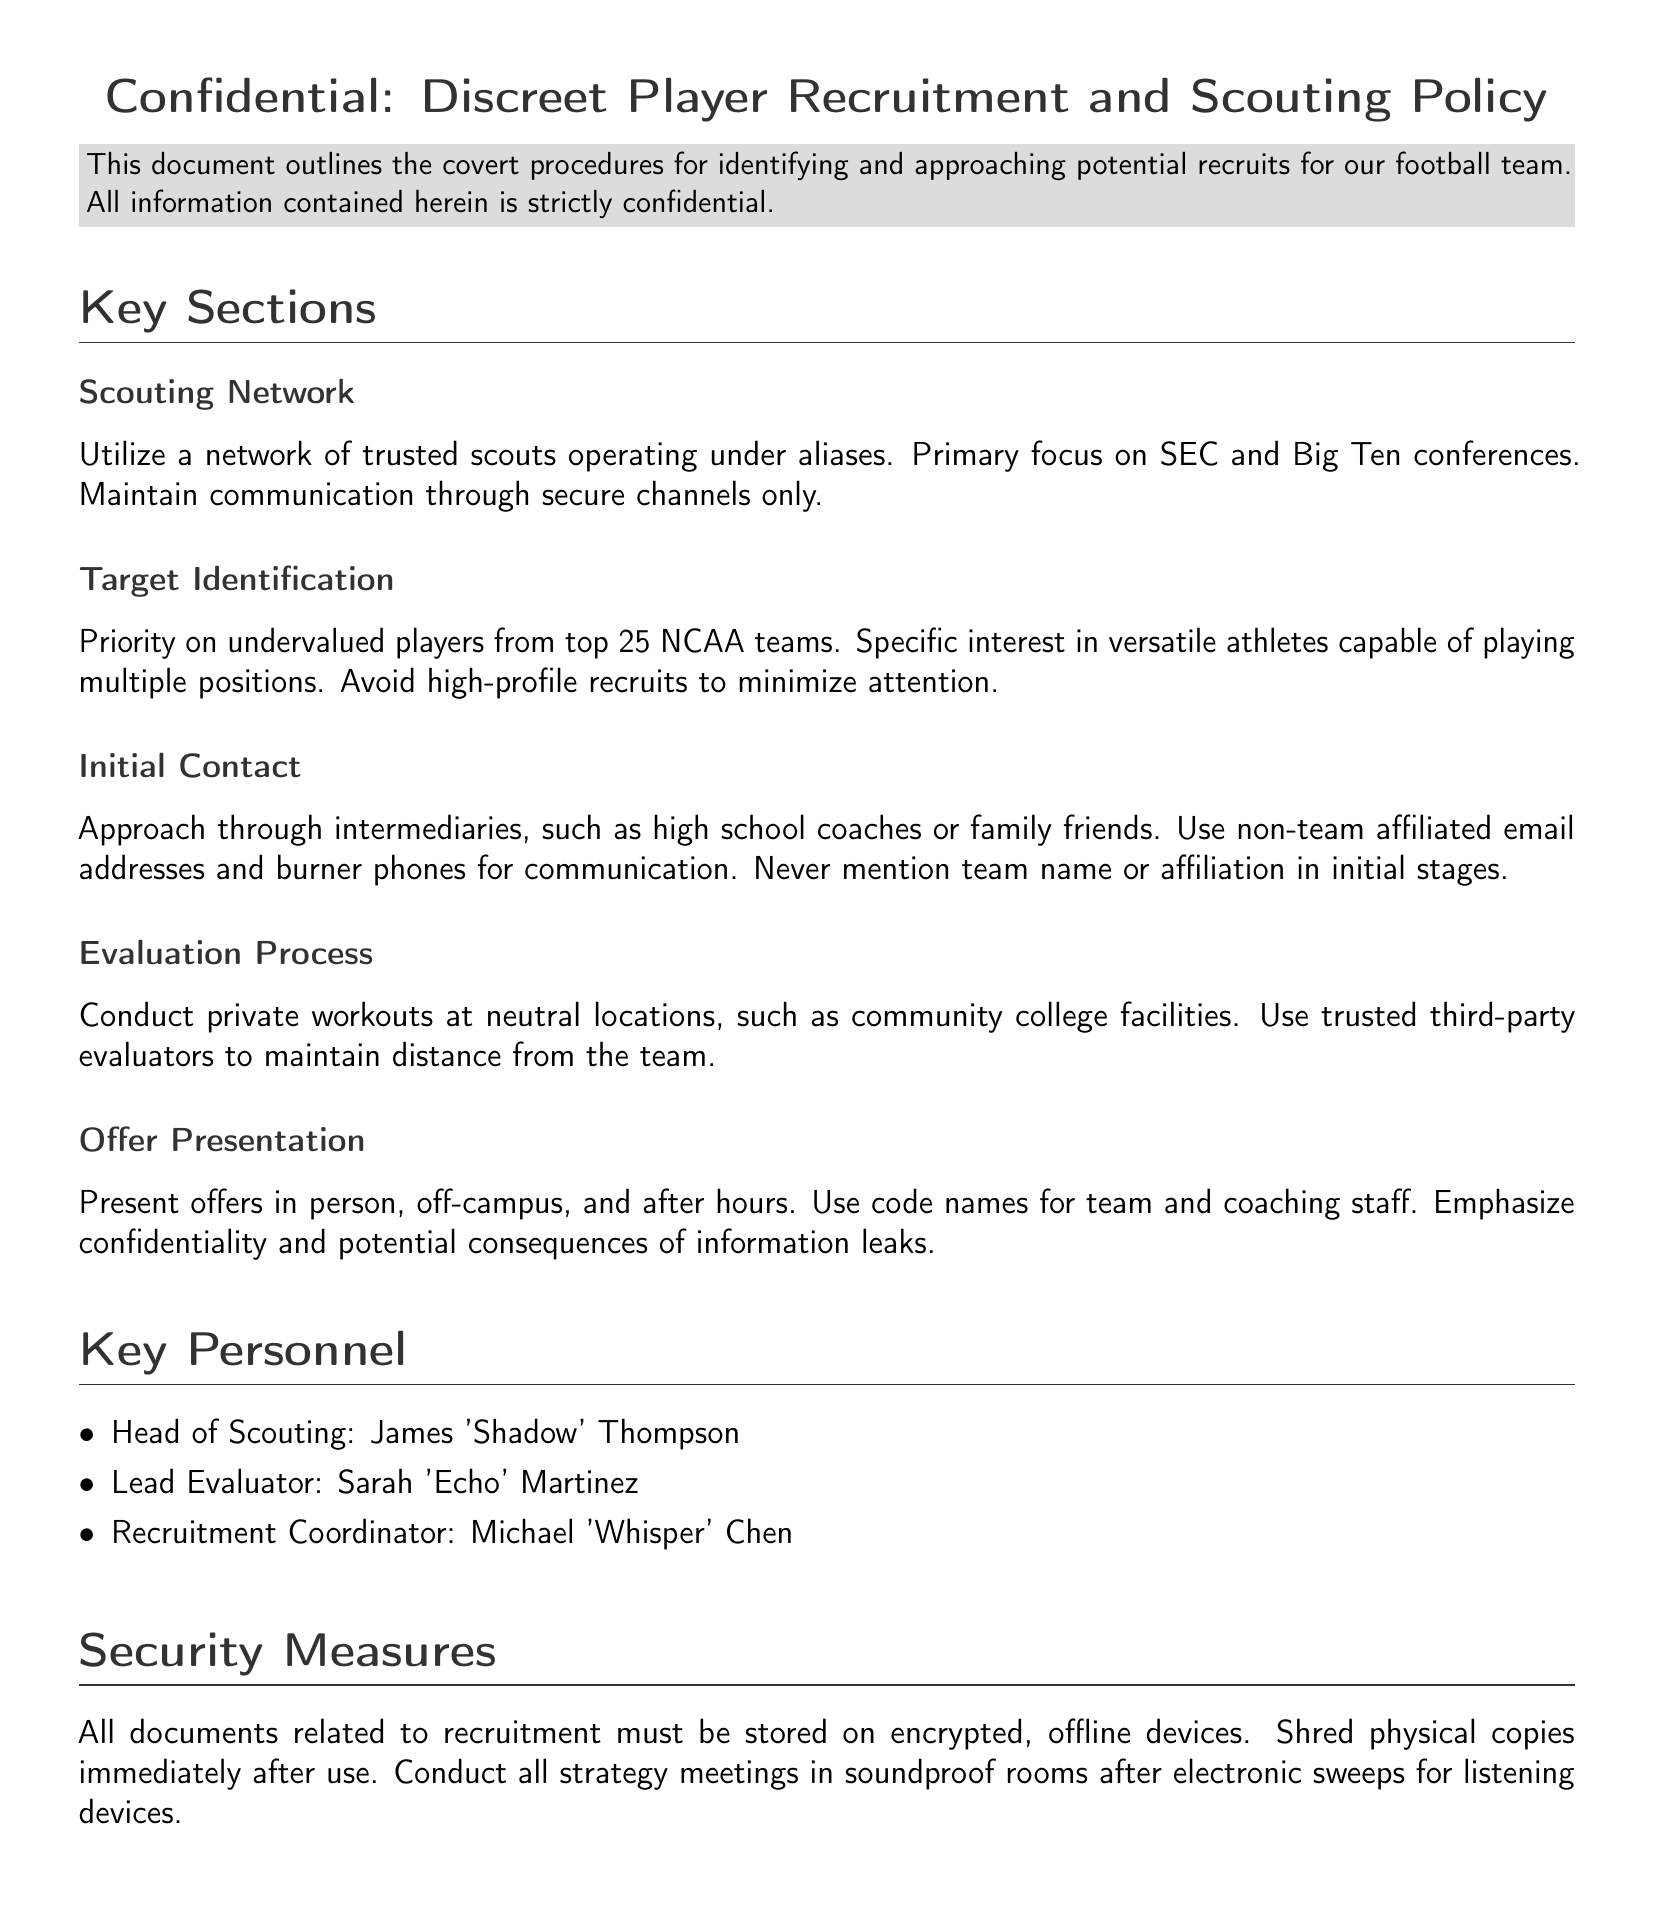What is the document title? The title of the document is presented in the header section at the beginning.
Answer: Confidential: Discreet Player Recruitment and Scouting Policy Who is the Head of Scouting? The document specifically states the key personnel and their roles.
Answer: James 'Shadow' Thompson What is the primary focus of the scouting network? The document outlines the primary focus of the scouting network under the scouting network section.
Answer: SEC and Big Ten conferences What type of players are prioritized for recruitment? The target identification section specifies the particular type of players that are prioritized.
Answer: Undervalued players What should be maintained during initial contact? The initial contact section highlights an important aspect to be maintained during communication.
Answer: Confidentiality Where should private workouts be conducted? The evaluation process section mentions a specific type of location for private workouts.
Answer: Neutral locations Who is the Recruitment Coordinator? A list of key personnel is provided in the document with their corresponding titles.
Answer: Michael 'Whisper' Chen What security measures are recommended for documents? The security measures section describes how documents related to recruitment should be handled.
Answer: Encrypted, offline devices 